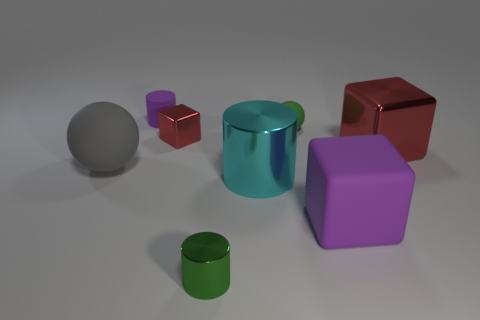What number of other things are the same color as the matte cylinder?
Ensure brevity in your answer.  1. The other metal thing that is the same shape as the cyan metal thing is what size?
Provide a short and direct response. Small. There is a big metal thing that is right of the tiny green ball; is its color the same as the tiny metal cube?
Keep it short and to the point. Yes. There is a rubber cube; is it the same color as the cylinder that is behind the cyan thing?
Ensure brevity in your answer.  Yes. There is a green metal thing; are there any purple rubber cylinders in front of it?
Provide a succinct answer. No. Is the material of the small green sphere the same as the purple cube?
Your answer should be compact. Yes. What is the material of the purple cube that is the same size as the gray rubber object?
Your answer should be very brief. Rubber. What number of objects are tiny objects that are left of the large cylinder or blue matte spheres?
Offer a very short reply. 3. Are there the same number of tiny purple cylinders left of the tiny green ball and big cylinders?
Your response must be concise. Yes. Is the color of the matte cylinder the same as the matte cube?
Offer a terse response. Yes. 